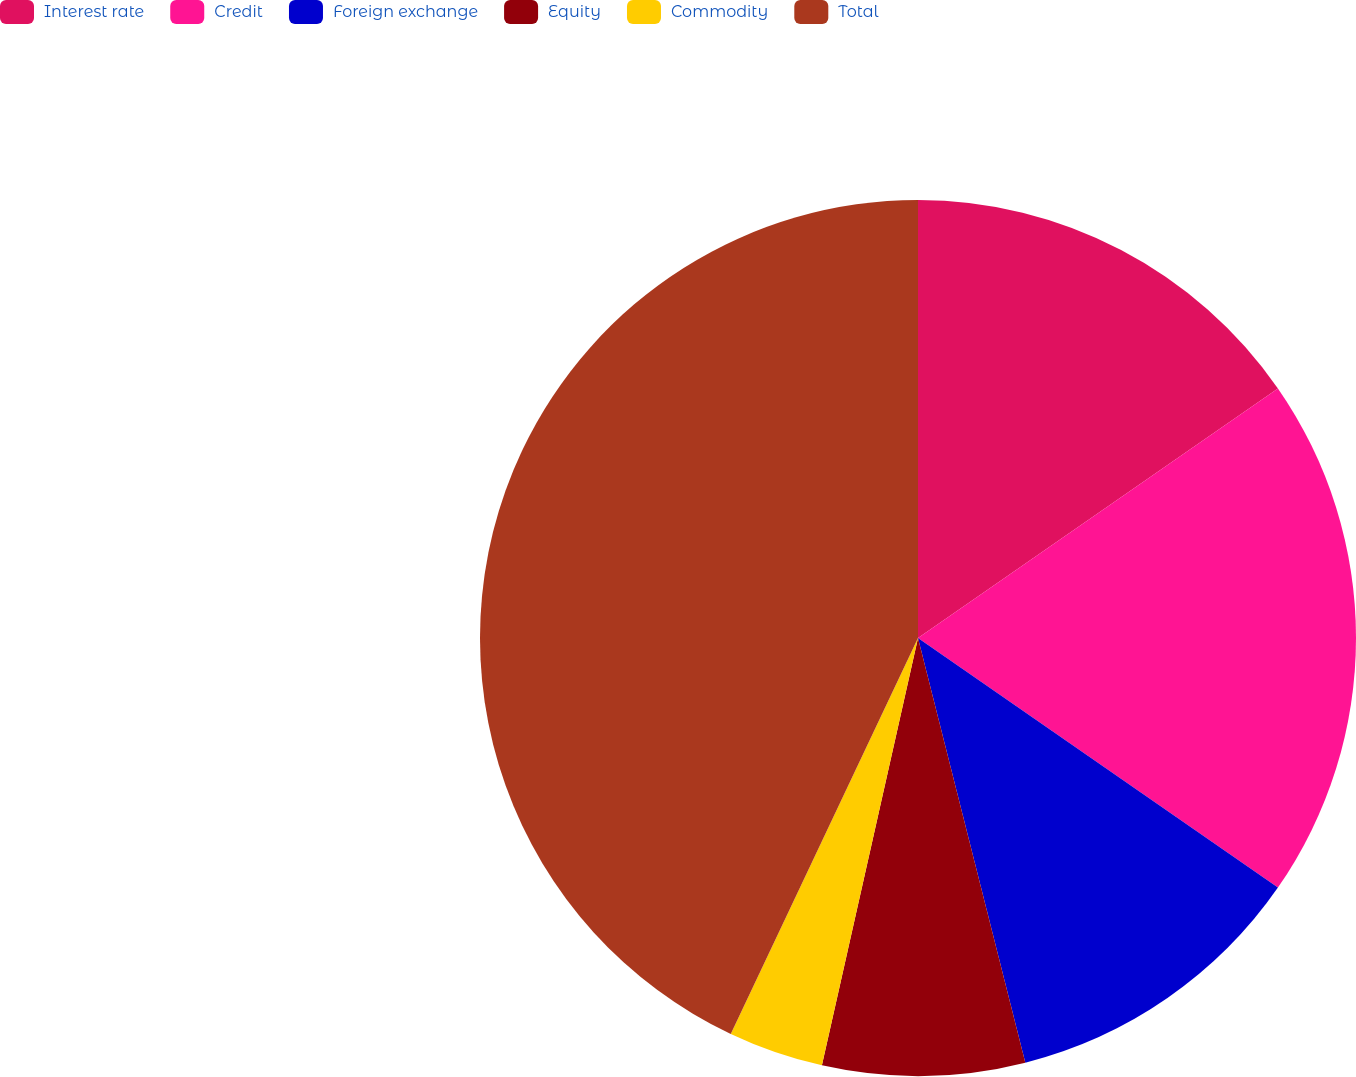Convert chart. <chart><loc_0><loc_0><loc_500><loc_500><pie_chart><fcel>Interest rate<fcel>Credit<fcel>Foreign exchange<fcel>Equity<fcel>Commodity<fcel>Total<nl><fcel>15.35%<fcel>19.3%<fcel>11.41%<fcel>7.46%<fcel>3.51%<fcel>42.97%<nl></chart> 